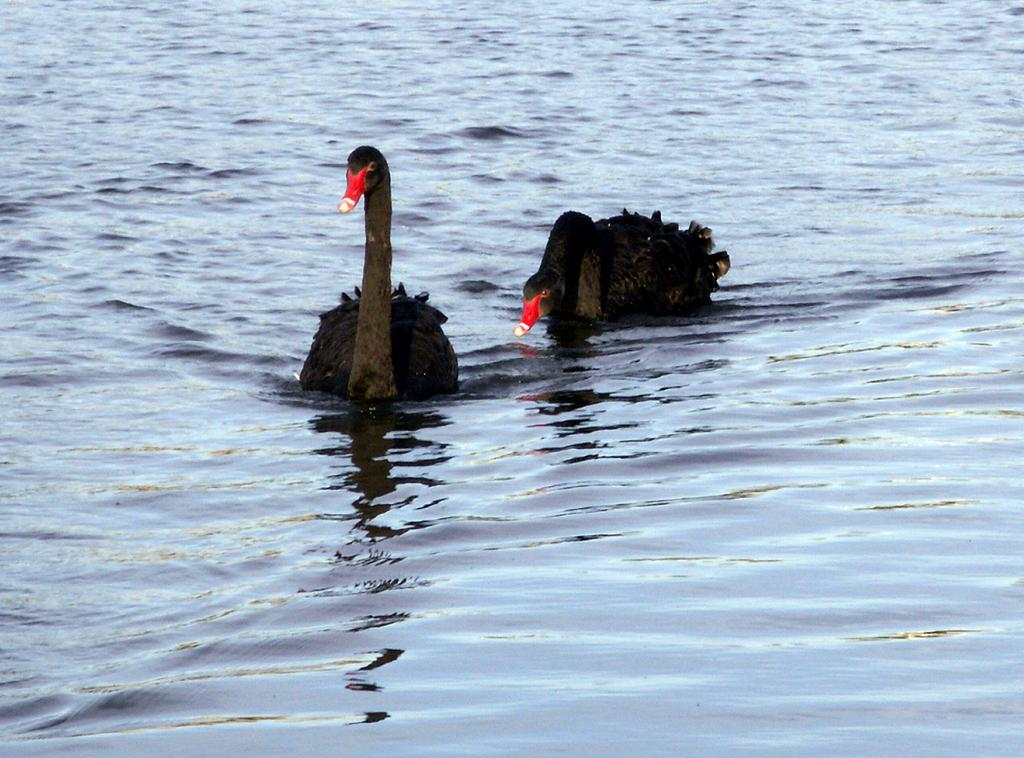What animals are present in the image? There are two black swans in the image. What are the swans doing in the image? The swans are swimming in the water. Can you describe the environment where the swans are located? The water might be in a pond. What is unique about one of the swans? One of the swans has a red color beak. What is the reaction of the swans to the root vegetable in the image? There is no root vegetable present in the image, so the swans' reaction cannot be determined. 